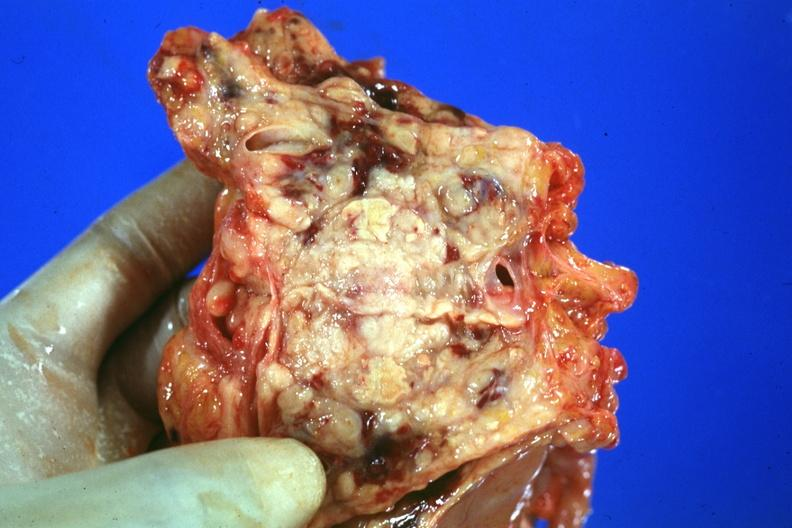how is prostate cut showing neoplasm quite good?
Answer the question using a single word or phrase. Open 